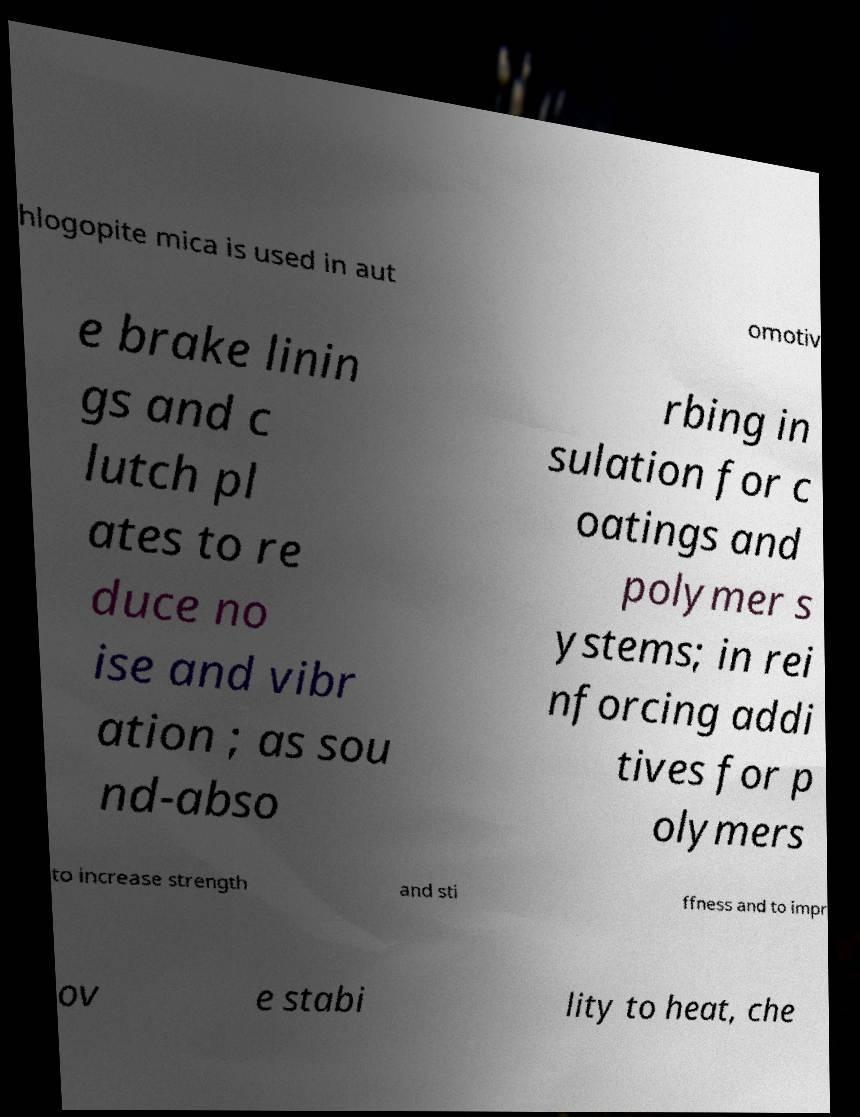Could you extract and type out the text from this image? hlogopite mica is used in aut omotiv e brake linin gs and c lutch pl ates to re duce no ise and vibr ation ; as sou nd-abso rbing in sulation for c oatings and polymer s ystems; in rei nforcing addi tives for p olymers to increase strength and sti ffness and to impr ov e stabi lity to heat, che 